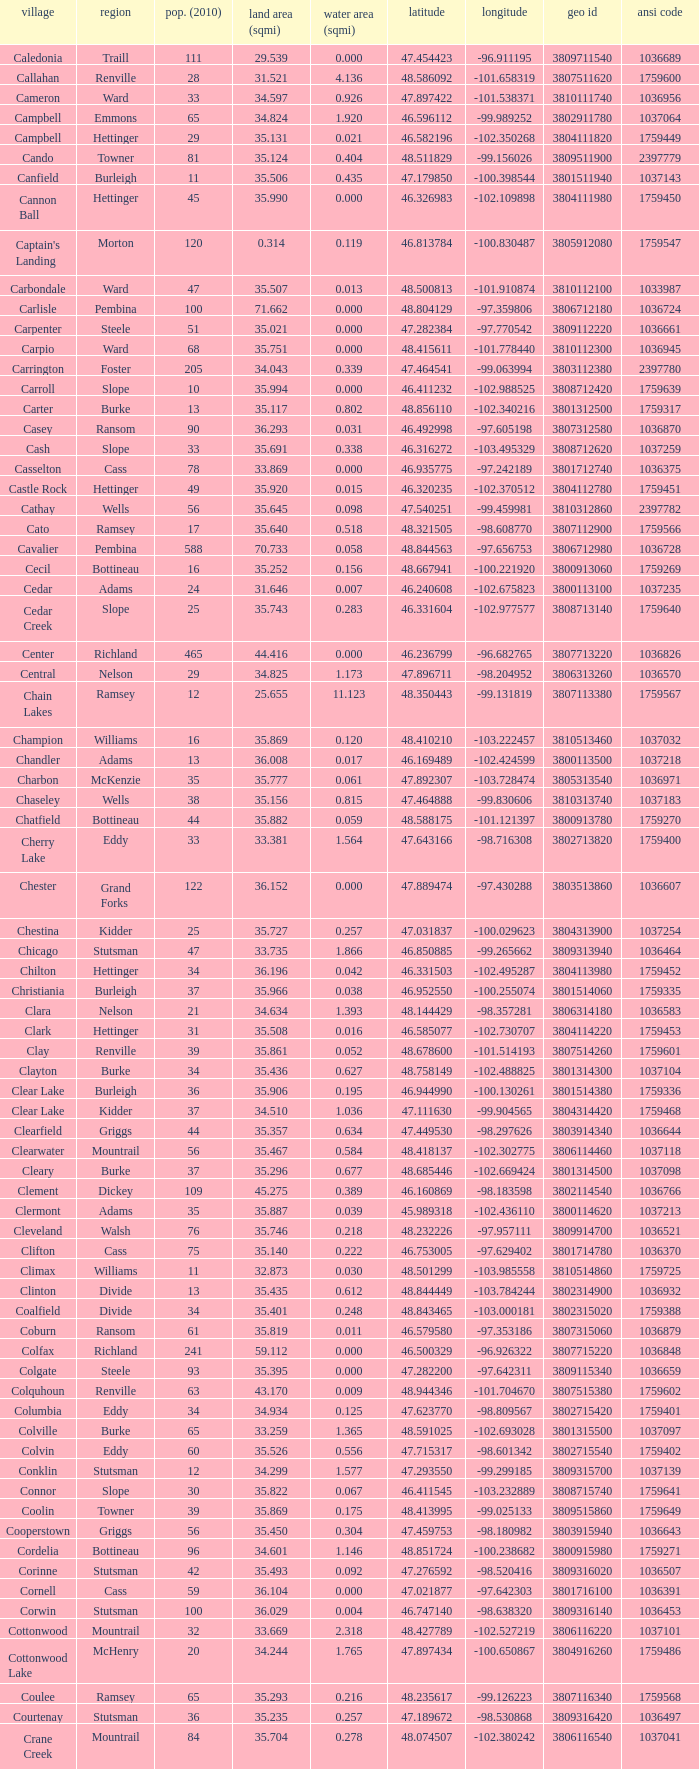What was the county with a latitude of 46.770977? Kidder. 